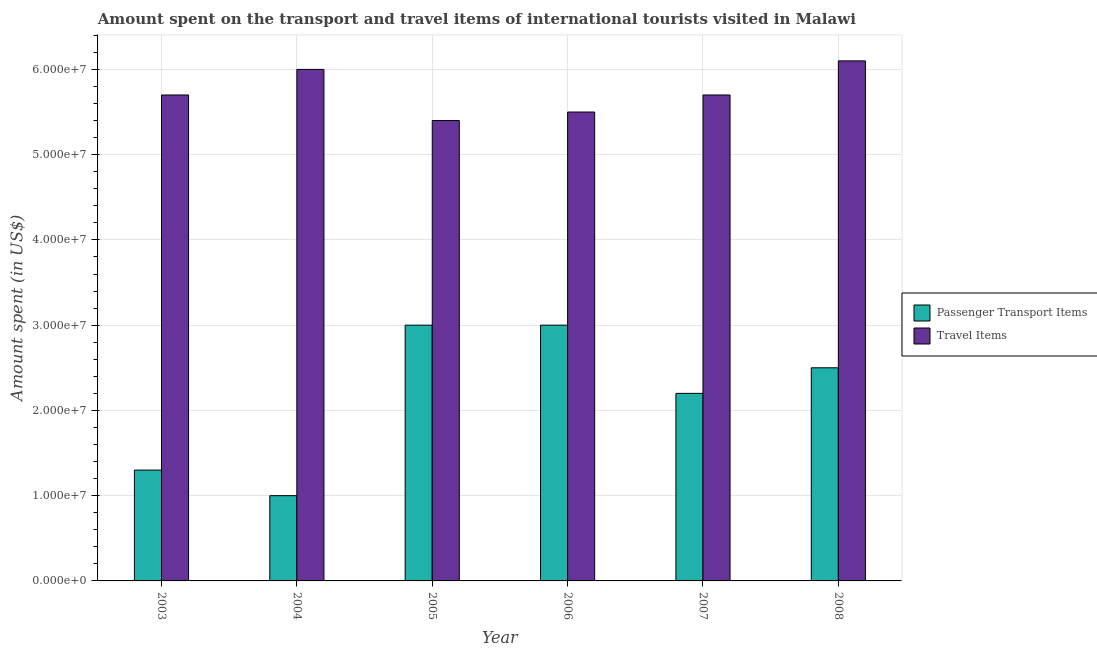Are the number of bars per tick equal to the number of legend labels?
Provide a short and direct response. Yes. How many bars are there on the 5th tick from the left?
Your answer should be very brief. 2. How many bars are there on the 4th tick from the right?
Offer a terse response. 2. What is the label of the 2nd group of bars from the left?
Your answer should be compact. 2004. In how many cases, is the number of bars for a given year not equal to the number of legend labels?
Offer a very short reply. 0. What is the amount spent on passenger transport items in 2008?
Ensure brevity in your answer.  2.50e+07. Across all years, what is the maximum amount spent on passenger transport items?
Provide a short and direct response. 3.00e+07. Across all years, what is the minimum amount spent on passenger transport items?
Offer a terse response. 1.00e+07. What is the total amount spent in travel items in the graph?
Your answer should be very brief. 3.44e+08. What is the difference between the amount spent in travel items in 2004 and that in 2008?
Make the answer very short. -1.00e+06. What is the difference between the amount spent on passenger transport items in 2005 and the amount spent in travel items in 2008?
Your answer should be very brief. 5.00e+06. What is the average amount spent on passenger transport items per year?
Provide a succinct answer. 2.17e+07. In the year 2003, what is the difference between the amount spent on passenger transport items and amount spent in travel items?
Your answer should be very brief. 0. In how many years, is the amount spent on passenger transport items greater than 58000000 US$?
Ensure brevity in your answer.  0. Is the amount spent in travel items in 2005 less than that in 2008?
Ensure brevity in your answer.  Yes. What is the difference between the highest and the second highest amount spent on passenger transport items?
Offer a terse response. 0. What is the difference between the highest and the lowest amount spent on passenger transport items?
Your answer should be compact. 2.00e+07. What does the 1st bar from the left in 2004 represents?
Give a very brief answer. Passenger Transport Items. What does the 2nd bar from the right in 2003 represents?
Your answer should be compact. Passenger Transport Items. How many bars are there?
Your response must be concise. 12. How many years are there in the graph?
Give a very brief answer. 6. Are the values on the major ticks of Y-axis written in scientific E-notation?
Make the answer very short. Yes. Does the graph contain any zero values?
Make the answer very short. No. Where does the legend appear in the graph?
Provide a succinct answer. Center right. How many legend labels are there?
Ensure brevity in your answer.  2. What is the title of the graph?
Ensure brevity in your answer.  Amount spent on the transport and travel items of international tourists visited in Malawi. Does "Nitrous oxide emissions" appear as one of the legend labels in the graph?
Offer a terse response. No. What is the label or title of the X-axis?
Ensure brevity in your answer.  Year. What is the label or title of the Y-axis?
Provide a succinct answer. Amount spent (in US$). What is the Amount spent (in US$) of Passenger Transport Items in 2003?
Offer a very short reply. 1.30e+07. What is the Amount spent (in US$) in Travel Items in 2003?
Make the answer very short. 5.70e+07. What is the Amount spent (in US$) in Travel Items in 2004?
Make the answer very short. 6.00e+07. What is the Amount spent (in US$) in Passenger Transport Items in 2005?
Offer a terse response. 3.00e+07. What is the Amount spent (in US$) of Travel Items in 2005?
Provide a short and direct response. 5.40e+07. What is the Amount spent (in US$) in Passenger Transport Items in 2006?
Keep it short and to the point. 3.00e+07. What is the Amount spent (in US$) in Travel Items in 2006?
Make the answer very short. 5.50e+07. What is the Amount spent (in US$) in Passenger Transport Items in 2007?
Your response must be concise. 2.20e+07. What is the Amount spent (in US$) of Travel Items in 2007?
Provide a succinct answer. 5.70e+07. What is the Amount spent (in US$) in Passenger Transport Items in 2008?
Your answer should be very brief. 2.50e+07. What is the Amount spent (in US$) in Travel Items in 2008?
Provide a succinct answer. 6.10e+07. Across all years, what is the maximum Amount spent (in US$) in Passenger Transport Items?
Give a very brief answer. 3.00e+07. Across all years, what is the maximum Amount spent (in US$) in Travel Items?
Offer a terse response. 6.10e+07. Across all years, what is the minimum Amount spent (in US$) of Travel Items?
Your answer should be compact. 5.40e+07. What is the total Amount spent (in US$) in Passenger Transport Items in the graph?
Your response must be concise. 1.30e+08. What is the total Amount spent (in US$) in Travel Items in the graph?
Ensure brevity in your answer.  3.44e+08. What is the difference between the Amount spent (in US$) of Travel Items in 2003 and that in 2004?
Your response must be concise. -3.00e+06. What is the difference between the Amount spent (in US$) of Passenger Transport Items in 2003 and that in 2005?
Make the answer very short. -1.70e+07. What is the difference between the Amount spent (in US$) in Travel Items in 2003 and that in 2005?
Keep it short and to the point. 3.00e+06. What is the difference between the Amount spent (in US$) of Passenger Transport Items in 2003 and that in 2006?
Make the answer very short. -1.70e+07. What is the difference between the Amount spent (in US$) in Passenger Transport Items in 2003 and that in 2007?
Provide a succinct answer. -9.00e+06. What is the difference between the Amount spent (in US$) in Travel Items in 2003 and that in 2007?
Offer a terse response. 0. What is the difference between the Amount spent (in US$) in Passenger Transport Items in 2003 and that in 2008?
Your answer should be very brief. -1.20e+07. What is the difference between the Amount spent (in US$) of Travel Items in 2003 and that in 2008?
Keep it short and to the point. -4.00e+06. What is the difference between the Amount spent (in US$) of Passenger Transport Items in 2004 and that in 2005?
Your response must be concise. -2.00e+07. What is the difference between the Amount spent (in US$) of Travel Items in 2004 and that in 2005?
Ensure brevity in your answer.  6.00e+06. What is the difference between the Amount spent (in US$) of Passenger Transport Items in 2004 and that in 2006?
Give a very brief answer. -2.00e+07. What is the difference between the Amount spent (in US$) in Passenger Transport Items in 2004 and that in 2007?
Make the answer very short. -1.20e+07. What is the difference between the Amount spent (in US$) of Travel Items in 2004 and that in 2007?
Provide a succinct answer. 3.00e+06. What is the difference between the Amount spent (in US$) of Passenger Transport Items in 2004 and that in 2008?
Ensure brevity in your answer.  -1.50e+07. What is the difference between the Amount spent (in US$) in Travel Items in 2004 and that in 2008?
Offer a very short reply. -1.00e+06. What is the difference between the Amount spent (in US$) in Passenger Transport Items in 2005 and that in 2006?
Offer a terse response. 0. What is the difference between the Amount spent (in US$) in Travel Items in 2005 and that in 2006?
Offer a terse response. -1.00e+06. What is the difference between the Amount spent (in US$) in Travel Items in 2005 and that in 2007?
Your response must be concise. -3.00e+06. What is the difference between the Amount spent (in US$) of Passenger Transport Items in 2005 and that in 2008?
Keep it short and to the point. 5.00e+06. What is the difference between the Amount spent (in US$) of Travel Items in 2005 and that in 2008?
Your answer should be compact. -7.00e+06. What is the difference between the Amount spent (in US$) in Passenger Transport Items in 2006 and that in 2008?
Ensure brevity in your answer.  5.00e+06. What is the difference between the Amount spent (in US$) of Travel Items in 2006 and that in 2008?
Give a very brief answer. -6.00e+06. What is the difference between the Amount spent (in US$) of Passenger Transport Items in 2007 and that in 2008?
Your answer should be very brief. -3.00e+06. What is the difference between the Amount spent (in US$) in Passenger Transport Items in 2003 and the Amount spent (in US$) in Travel Items in 2004?
Your answer should be compact. -4.70e+07. What is the difference between the Amount spent (in US$) of Passenger Transport Items in 2003 and the Amount spent (in US$) of Travel Items in 2005?
Make the answer very short. -4.10e+07. What is the difference between the Amount spent (in US$) in Passenger Transport Items in 2003 and the Amount spent (in US$) in Travel Items in 2006?
Keep it short and to the point. -4.20e+07. What is the difference between the Amount spent (in US$) of Passenger Transport Items in 2003 and the Amount spent (in US$) of Travel Items in 2007?
Keep it short and to the point. -4.40e+07. What is the difference between the Amount spent (in US$) in Passenger Transport Items in 2003 and the Amount spent (in US$) in Travel Items in 2008?
Provide a short and direct response. -4.80e+07. What is the difference between the Amount spent (in US$) in Passenger Transport Items in 2004 and the Amount spent (in US$) in Travel Items in 2005?
Your response must be concise. -4.40e+07. What is the difference between the Amount spent (in US$) of Passenger Transport Items in 2004 and the Amount spent (in US$) of Travel Items in 2006?
Offer a very short reply. -4.50e+07. What is the difference between the Amount spent (in US$) in Passenger Transport Items in 2004 and the Amount spent (in US$) in Travel Items in 2007?
Your response must be concise. -4.70e+07. What is the difference between the Amount spent (in US$) in Passenger Transport Items in 2004 and the Amount spent (in US$) in Travel Items in 2008?
Your response must be concise. -5.10e+07. What is the difference between the Amount spent (in US$) of Passenger Transport Items in 2005 and the Amount spent (in US$) of Travel Items in 2006?
Your answer should be compact. -2.50e+07. What is the difference between the Amount spent (in US$) of Passenger Transport Items in 2005 and the Amount spent (in US$) of Travel Items in 2007?
Make the answer very short. -2.70e+07. What is the difference between the Amount spent (in US$) of Passenger Transport Items in 2005 and the Amount spent (in US$) of Travel Items in 2008?
Your answer should be compact. -3.10e+07. What is the difference between the Amount spent (in US$) of Passenger Transport Items in 2006 and the Amount spent (in US$) of Travel Items in 2007?
Offer a very short reply. -2.70e+07. What is the difference between the Amount spent (in US$) in Passenger Transport Items in 2006 and the Amount spent (in US$) in Travel Items in 2008?
Provide a short and direct response. -3.10e+07. What is the difference between the Amount spent (in US$) in Passenger Transport Items in 2007 and the Amount spent (in US$) in Travel Items in 2008?
Your answer should be compact. -3.90e+07. What is the average Amount spent (in US$) in Passenger Transport Items per year?
Offer a terse response. 2.17e+07. What is the average Amount spent (in US$) in Travel Items per year?
Your answer should be compact. 5.73e+07. In the year 2003, what is the difference between the Amount spent (in US$) of Passenger Transport Items and Amount spent (in US$) of Travel Items?
Offer a terse response. -4.40e+07. In the year 2004, what is the difference between the Amount spent (in US$) of Passenger Transport Items and Amount spent (in US$) of Travel Items?
Offer a terse response. -5.00e+07. In the year 2005, what is the difference between the Amount spent (in US$) in Passenger Transport Items and Amount spent (in US$) in Travel Items?
Provide a succinct answer. -2.40e+07. In the year 2006, what is the difference between the Amount spent (in US$) of Passenger Transport Items and Amount spent (in US$) of Travel Items?
Provide a succinct answer. -2.50e+07. In the year 2007, what is the difference between the Amount spent (in US$) of Passenger Transport Items and Amount spent (in US$) of Travel Items?
Offer a terse response. -3.50e+07. In the year 2008, what is the difference between the Amount spent (in US$) in Passenger Transport Items and Amount spent (in US$) in Travel Items?
Your answer should be compact. -3.60e+07. What is the ratio of the Amount spent (in US$) in Travel Items in 2003 to that in 2004?
Give a very brief answer. 0.95. What is the ratio of the Amount spent (in US$) of Passenger Transport Items in 2003 to that in 2005?
Your answer should be very brief. 0.43. What is the ratio of the Amount spent (in US$) of Travel Items in 2003 to that in 2005?
Your answer should be compact. 1.06. What is the ratio of the Amount spent (in US$) of Passenger Transport Items in 2003 to that in 2006?
Ensure brevity in your answer.  0.43. What is the ratio of the Amount spent (in US$) in Travel Items in 2003 to that in 2006?
Give a very brief answer. 1.04. What is the ratio of the Amount spent (in US$) of Passenger Transport Items in 2003 to that in 2007?
Make the answer very short. 0.59. What is the ratio of the Amount spent (in US$) in Travel Items in 2003 to that in 2007?
Offer a terse response. 1. What is the ratio of the Amount spent (in US$) of Passenger Transport Items in 2003 to that in 2008?
Your response must be concise. 0.52. What is the ratio of the Amount spent (in US$) in Travel Items in 2003 to that in 2008?
Provide a short and direct response. 0.93. What is the ratio of the Amount spent (in US$) of Passenger Transport Items in 2004 to that in 2006?
Provide a short and direct response. 0.33. What is the ratio of the Amount spent (in US$) of Passenger Transport Items in 2004 to that in 2007?
Your answer should be compact. 0.45. What is the ratio of the Amount spent (in US$) of Travel Items in 2004 to that in 2007?
Your answer should be compact. 1.05. What is the ratio of the Amount spent (in US$) in Passenger Transport Items in 2004 to that in 2008?
Your answer should be compact. 0.4. What is the ratio of the Amount spent (in US$) in Travel Items in 2004 to that in 2008?
Offer a terse response. 0.98. What is the ratio of the Amount spent (in US$) in Travel Items in 2005 to that in 2006?
Provide a succinct answer. 0.98. What is the ratio of the Amount spent (in US$) in Passenger Transport Items in 2005 to that in 2007?
Make the answer very short. 1.36. What is the ratio of the Amount spent (in US$) in Passenger Transport Items in 2005 to that in 2008?
Your answer should be very brief. 1.2. What is the ratio of the Amount spent (in US$) in Travel Items in 2005 to that in 2008?
Offer a very short reply. 0.89. What is the ratio of the Amount spent (in US$) in Passenger Transport Items in 2006 to that in 2007?
Offer a very short reply. 1.36. What is the ratio of the Amount spent (in US$) of Travel Items in 2006 to that in 2007?
Give a very brief answer. 0.96. What is the ratio of the Amount spent (in US$) in Passenger Transport Items in 2006 to that in 2008?
Ensure brevity in your answer.  1.2. What is the ratio of the Amount spent (in US$) of Travel Items in 2006 to that in 2008?
Your answer should be very brief. 0.9. What is the ratio of the Amount spent (in US$) in Travel Items in 2007 to that in 2008?
Offer a very short reply. 0.93. What is the difference between the highest and the second highest Amount spent (in US$) of Passenger Transport Items?
Make the answer very short. 0. What is the difference between the highest and the lowest Amount spent (in US$) of Passenger Transport Items?
Give a very brief answer. 2.00e+07. What is the difference between the highest and the lowest Amount spent (in US$) of Travel Items?
Your answer should be compact. 7.00e+06. 